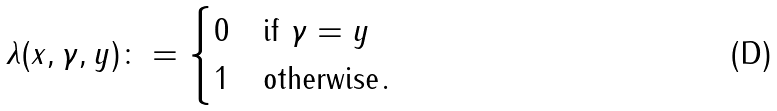Convert formula to latex. <formula><loc_0><loc_0><loc_500><loc_500>\lambda ( x , \gamma , y ) \colon = \begin{cases} 0 & \text {if $\gamma=y$} \\ 1 & \text {otherwise} . \end{cases}</formula> 